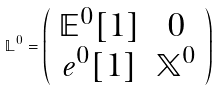<formula> <loc_0><loc_0><loc_500><loc_500>\mathbb { L } ^ { 0 } = \left ( \begin{array} { c c } \mathbb { E } ^ { 0 } [ 1 ] & 0 \\ e ^ { 0 } [ 1 ] & \mathbb { X } ^ { 0 } \end{array} \right )</formula> 